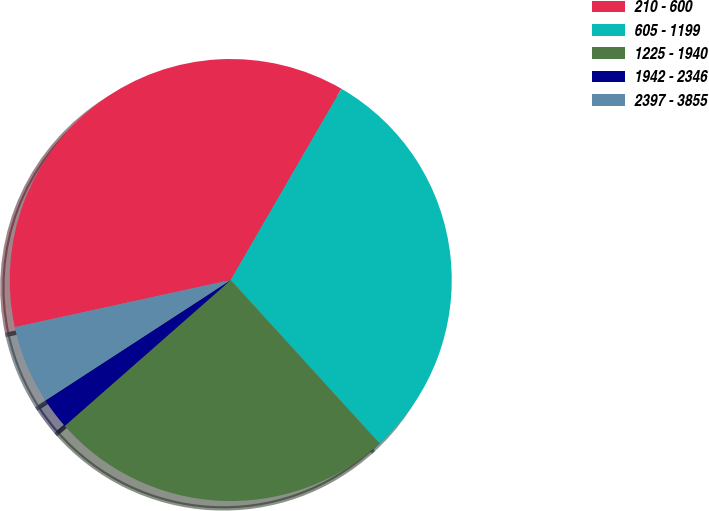Convert chart. <chart><loc_0><loc_0><loc_500><loc_500><pie_chart><fcel>210 - 600<fcel>605 - 1199<fcel>1225 - 1940<fcel>1942 - 2346<fcel>2397 - 3855<nl><fcel>36.78%<fcel>29.89%<fcel>25.29%<fcel>2.3%<fcel>5.75%<nl></chart> 